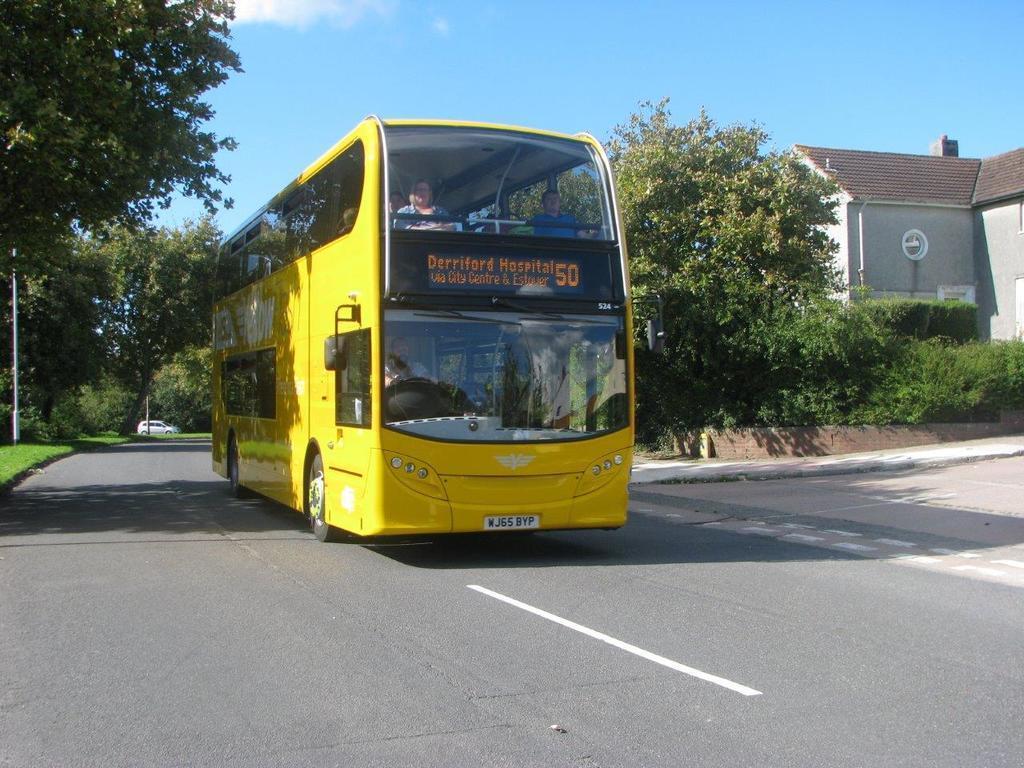Describe this image in one or two sentences. In this image I can see the road. On the road there are two vehicle which are in white and yellow color. I can see few people are sitting on one of the vehicle. To the side of the road there are trees and house. In the back I can see the blue sky. 